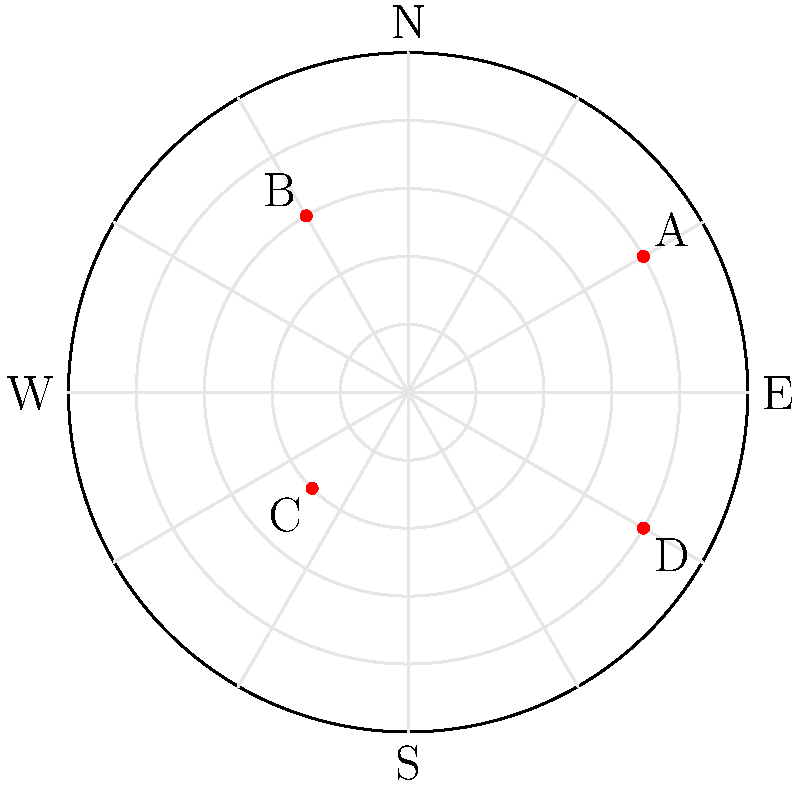As a military social worker, you're analyzing the deployment locations of four veteran support units on a polar grid. The units are located at points A $(4, \frac{\pi}{6})$, B $(3, \frac{2\pi}{3})$, C $(2, \frac{5\pi}{4})$, and D $(4, \frac{11\pi}{6})$ in polar coordinates $(r, \theta)$. Which unit is positioned closest to the southwest direction? To determine which unit is closest to the southwest direction, we need to follow these steps:

1. Recall that southwest is at an angle of $\frac{5\pi}{4}$ or 225° on the polar grid.

2. Compare the angular positions of each unit to $\frac{5\pi}{4}$:
   A: $\frac{\pi}{6}$ (30°)
   B: $\frac{2\pi}{3}$ (120°)
   C: $\frac{5\pi}{4}$ (225°)
   D: $\frac{11\pi}{6}$ (330°)

3. Unit C is exactly at $\frac{5\pi}{4}$, which is the southwest direction.

4. The other units are farther from the southwest direction:
   A is in the northeast quadrant
   B is in the northwest quadrant
   D is in the southeast quadrant

5. Even though units A and D have a larger radius (4) compared to C (2), the angular position is more important for determining the direction.

Therefore, unit C is positioned closest to the southwest direction.
Answer: Unit C 